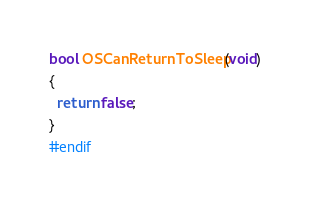Convert code to text. <code><loc_0><loc_0><loc_500><loc_500><_C_>bool OSCanReturnToSleep(void)
{
  return false;
}
#endif
</code> 